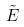Convert formula to latex. <formula><loc_0><loc_0><loc_500><loc_500>\tilde { E }</formula> 